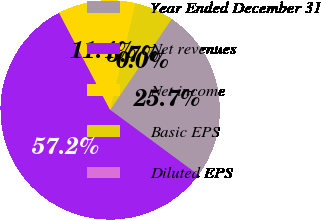<chart> <loc_0><loc_0><loc_500><loc_500><pie_chart><fcel>Year Ended December 31<fcel>Net revenues<fcel>Net income<fcel>Basic EPS<fcel>Diluted EPS<nl><fcel>25.66%<fcel>57.18%<fcel>11.44%<fcel>5.72%<fcel>0.0%<nl></chart> 